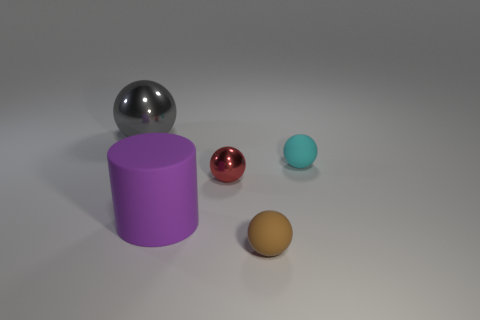What is the material of the small brown sphere?
Your answer should be compact. Rubber. The metallic object that is to the left of the purple rubber cylinder has what shape?
Offer a terse response. Sphere. Are there any cyan rubber things of the same size as the cyan sphere?
Offer a terse response. No. Are the small ball behind the tiny red metal ball and the big purple cylinder made of the same material?
Offer a terse response. Yes. Are there an equal number of red metallic spheres that are on the left side of the large gray metal object and gray things behind the purple cylinder?
Offer a very short reply. No. There is a object that is on the left side of the small red thing and in front of the cyan matte object; what shape is it?
Your answer should be very brief. Cylinder. How many small spheres are on the right side of the red metal thing?
Give a very brief answer. 2. How many other things are the same shape as the gray thing?
Your answer should be compact. 3. Are there fewer gray things than large yellow metal blocks?
Ensure brevity in your answer.  No. What size is the object that is to the left of the tiny cyan object and on the right side of the red thing?
Your answer should be very brief. Small. 